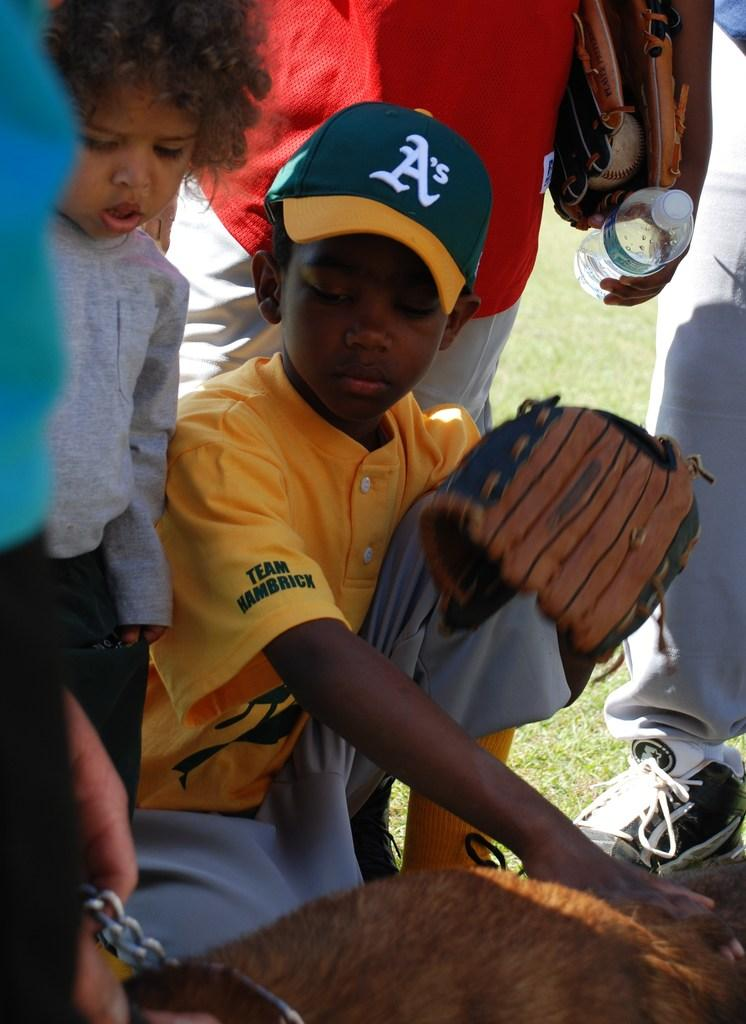<image>
Summarize the visual content of the image. Baseball player wearing a yellow jersey and a cap whiich says A. 